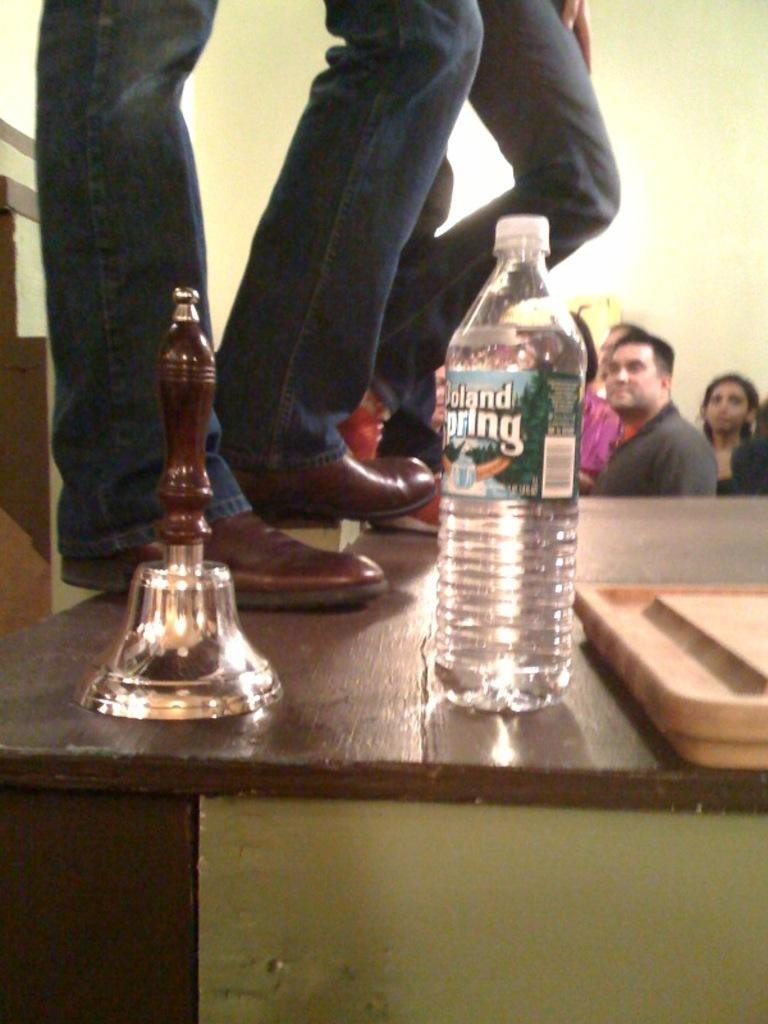What are the two persons doing in the image? The two persons are standing on the table. What objects can be seen on the table besides the persons? There is a bottle and a bell on the table. What can be observed in the background of the image? There is a group of people in the background of the image. Are there any fairies dancing on the stage in the image? There is no stage or fairies present in the image. Can you describe the girl sitting next to the bell? There is no girl present in the image; only two persons standing on the table and a group of people in the background are visible. 